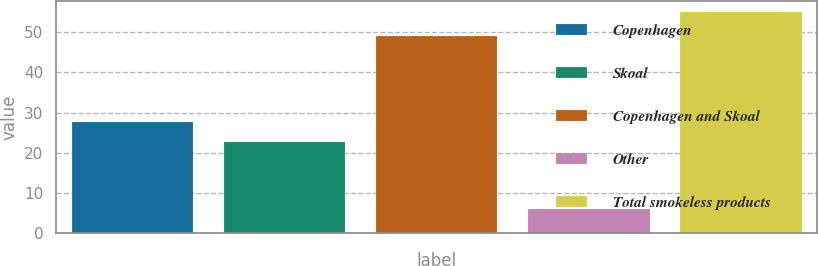<chart> <loc_0><loc_0><loc_500><loc_500><bar_chart><fcel>Copenhagen<fcel>Skoal<fcel>Copenhagen and Skoal<fcel>Other<fcel>Total smokeless products<nl><fcel>27.7<fcel>22.8<fcel>49<fcel>6.1<fcel>55.1<nl></chart> 